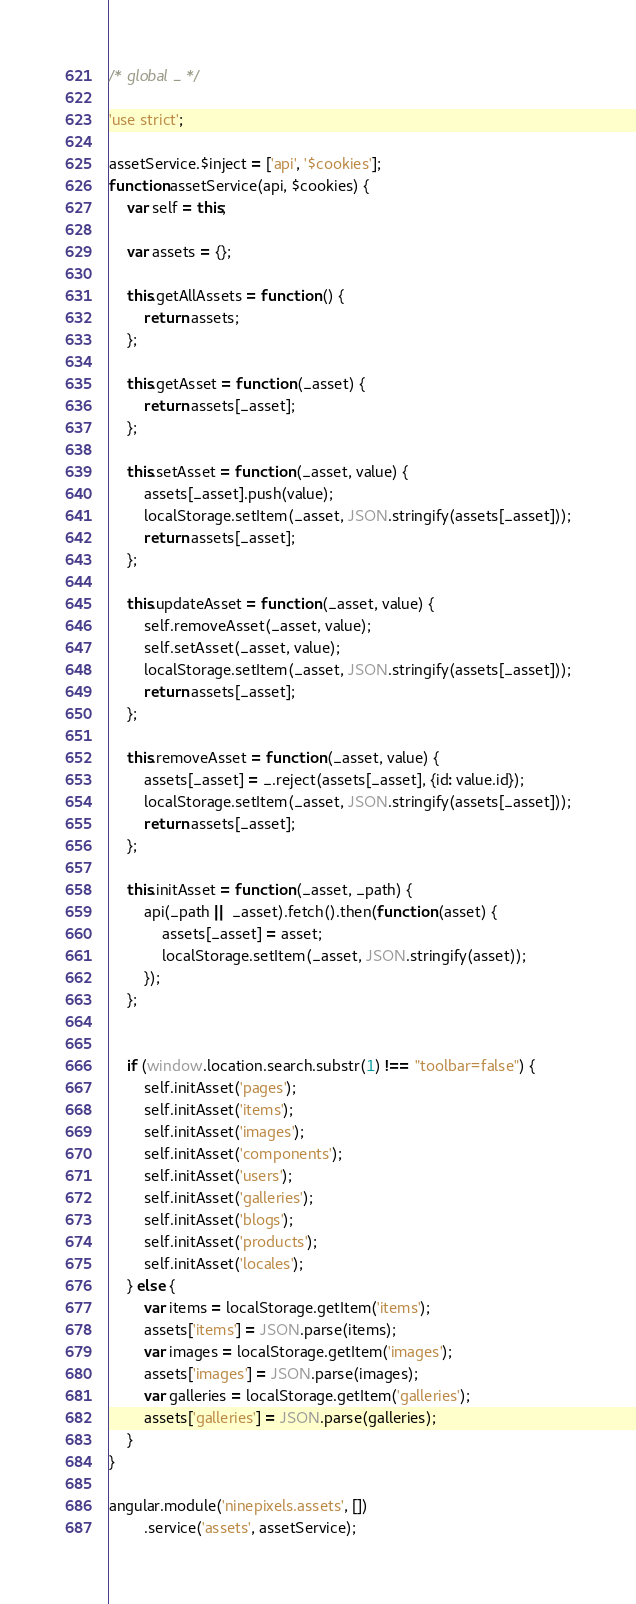<code> <loc_0><loc_0><loc_500><loc_500><_JavaScript_>/* global _ */

'use strict';

assetService.$inject = ['api', '$cookies'];
function assetService(api, $cookies) {
    var self = this;

    var assets = {};

    this.getAllAssets = function () {
        return assets;
    };

    this.getAsset = function (_asset) {
        return assets[_asset];
    };

    this.setAsset = function (_asset, value) {
        assets[_asset].push(value);
        localStorage.setItem(_asset, JSON.stringify(assets[_asset]));
        return assets[_asset];
    };

    this.updateAsset = function (_asset, value) {
        self.removeAsset(_asset, value);
        self.setAsset(_asset, value);
        localStorage.setItem(_asset, JSON.stringify(assets[_asset]));
        return assets[_asset];
    };

    this.removeAsset = function (_asset, value) {
        assets[_asset] = _.reject(assets[_asset], {id: value.id});
        localStorage.setItem(_asset, JSON.stringify(assets[_asset]));
        return assets[_asset];
    };

    this.initAsset = function (_asset, _path) {
        api(_path || _asset).fetch().then(function (asset) {
            assets[_asset] = asset;
            localStorage.setItem(_asset, JSON.stringify(asset));
        });
    };


    if (window.location.search.substr(1) !== "toolbar=false") {
        self.initAsset('pages');
        self.initAsset('items');
        self.initAsset('images');
        self.initAsset('components');
        self.initAsset('users');
        self.initAsset('galleries');
        self.initAsset('blogs');
        self.initAsset('products');
        self.initAsset('locales');
    } else {
        var items = localStorage.getItem('items');
        assets['items'] = JSON.parse(items);
        var images = localStorage.getItem('images');
        assets['images'] = JSON.parse(images);
        var galleries = localStorage.getItem('galleries');
        assets['galleries'] = JSON.parse(galleries);
    }
}

angular.module('ninepixels.assets', [])
        .service('assets', assetService);
</code> 